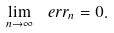<formula> <loc_0><loc_0><loc_500><loc_500>\lim _ { n \to \infty } \ e r r _ { n } = 0 .</formula> 